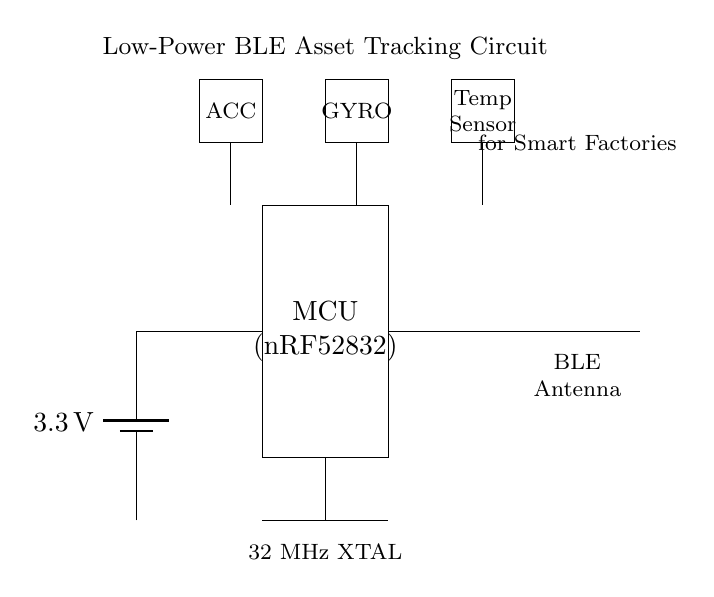What voltage does the power supply provide? The power supply in the circuit diagram is labeled as a battery with a voltage of 3.3 volts, therefore that is the voltage provided.
Answer: 3.3 volts What type of microcontroller is used? The diagram shows a rectangle with the label "MCU" and specifies the model "nRF52832" inside it, indicating this is the type of microcontroller used in the circuit.
Answer: nRF52832 How many sensors are included in the circuit? The circuit includes three sensor rectangles labeled as ACC, GYRO, and Temp Sensor, indicating that there are three sensors present in total.
Answer: Three sensors What is the function of the BLE antenna? The BLE antenna's function is to facilitate communication using Bluetooth Low Energy, which is essential for the asset tracking feature of this circuit, as indicated by the label near the antenna.
Answer: Communication Explain how the microcontroller connects to the sensors. The microcontroller has a line connecting to one point below it and another series of lines leading to each of the three sensors below, showing a direct connection for data communication between the microcontroller and each sensor.
Answer: Direct connections What is the purpose of the 32 MHz crystal oscillator? The specific function of the 32 MHz crystal oscillator is to provide a stable clock signal for the microcontroller, ensuring reliable operation and precise timing for data acquisition and communication processes across the circuit.
Answer: Provides stable clock signal 